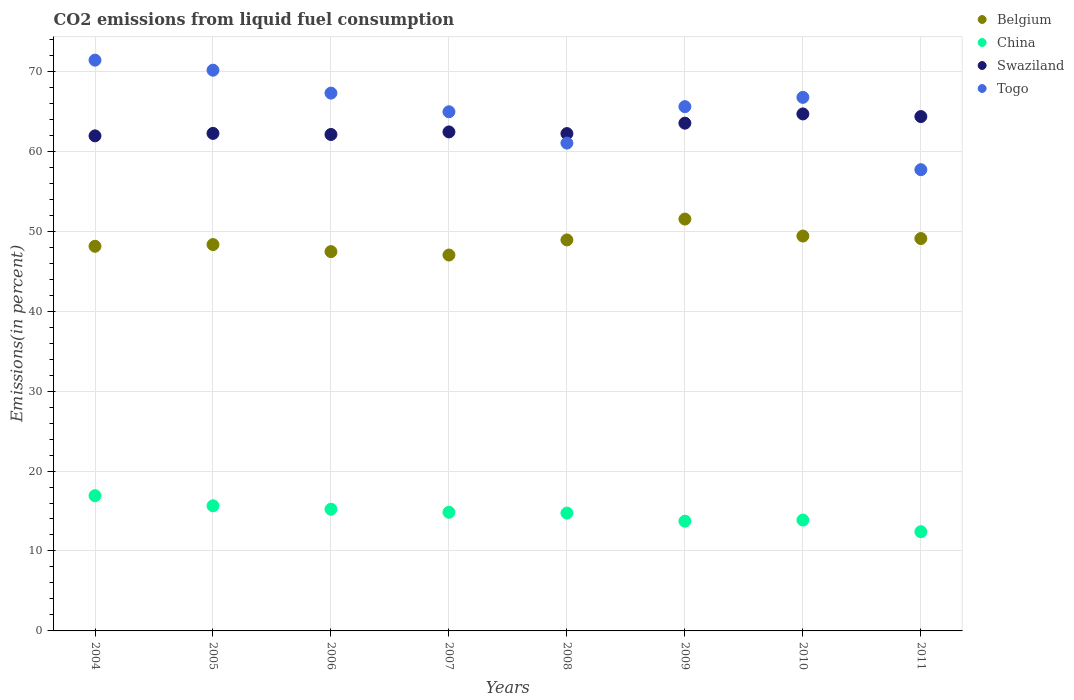What is the total CO2 emitted in China in 2010?
Provide a succinct answer. 13.87. Across all years, what is the maximum total CO2 emitted in China?
Ensure brevity in your answer.  16.91. Across all years, what is the minimum total CO2 emitted in China?
Make the answer very short. 12.41. In which year was the total CO2 emitted in Belgium maximum?
Ensure brevity in your answer.  2009. In which year was the total CO2 emitted in China minimum?
Keep it short and to the point. 2011. What is the total total CO2 emitted in Belgium in the graph?
Make the answer very short. 389.78. What is the difference between the total CO2 emitted in China in 2006 and that in 2008?
Provide a succinct answer. 0.48. What is the difference between the total CO2 emitted in Belgium in 2005 and the total CO2 emitted in Togo in 2008?
Ensure brevity in your answer.  -12.69. What is the average total CO2 emitted in Belgium per year?
Your answer should be very brief. 48.72. In the year 2009, what is the difference between the total CO2 emitted in China and total CO2 emitted in Belgium?
Provide a short and direct response. -37.79. What is the ratio of the total CO2 emitted in Belgium in 2009 to that in 2010?
Offer a terse response. 1.04. Is the total CO2 emitted in Belgium in 2004 less than that in 2010?
Make the answer very short. Yes. Is the difference between the total CO2 emitted in China in 2007 and 2009 greater than the difference between the total CO2 emitted in Belgium in 2007 and 2009?
Your answer should be very brief. Yes. What is the difference between the highest and the second highest total CO2 emitted in Belgium?
Offer a very short reply. 2.12. What is the difference between the highest and the lowest total CO2 emitted in China?
Offer a terse response. 4.5. Is the sum of the total CO2 emitted in China in 2004 and 2010 greater than the maximum total CO2 emitted in Belgium across all years?
Offer a very short reply. No. Is the total CO2 emitted in Togo strictly greater than the total CO2 emitted in China over the years?
Ensure brevity in your answer.  Yes. Is the total CO2 emitted in Swaziland strictly less than the total CO2 emitted in Belgium over the years?
Offer a terse response. No. How many dotlines are there?
Your response must be concise. 4. How many years are there in the graph?
Make the answer very short. 8. What is the difference between two consecutive major ticks on the Y-axis?
Provide a succinct answer. 10. How are the legend labels stacked?
Keep it short and to the point. Vertical. What is the title of the graph?
Give a very brief answer. CO2 emissions from liquid fuel consumption. What is the label or title of the X-axis?
Offer a very short reply. Years. What is the label or title of the Y-axis?
Your answer should be compact. Emissions(in percent). What is the Emissions(in percent) of Belgium in 2004?
Give a very brief answer. 48.11. What is the Emissions(in percent) in China in 2004?
Your answer should be very brief. 16.91. What is the Emissions(in percent) in Swaziland in 2004?
Provide a succinct answer. 61.92. What is the Emissions(in percent) of Togo in 2004?
Your answer should be very brief. 71.39. What is the Emissions(in percent) of Belgium in 2005?
Ensure brevity in your answer.  48.33. What is the Emissions(in percent) of China in 2005?
Your response must be concise. 15.65. What is the Emissions(in percent) in Swaziland in 2005?
Your answer should be compact. 62.23. What is the Emissions(in percent) in Togo in 2005?
Offer a very short reply. 70.14. What is the Emissions(in percent) of Belgium in 2006?
Your answer should be very brief. 47.44. What is the Emissions(in percent) of China in 2006?
Give a very brief answer. 15.22. What is the Emissions(in percent) of Swaziland in 2006?
Keep it short and to the point. 62.09. What is the Emissions(in percent) in Togo in 2006?
Your answer should be very brief. 67.27. What is the Emissions(in percent) in Belgium in 2007?
Offer a very short reply. 47.02. What is the Emissions(in percent) in China in 2007?
Make the answer very short. 14.84. What is the Emissions(in percent) in Swaziland in 2007?
Offer a very short reply. 62.41. What is the Emissions(in percent) in Togo in 2007?
Keep it short and to the point. 64.94. What is the Emissions(in percent) of Belgium in 2008?
Give a very brief answer. 48.9. What is the Emissions(in percent) in China in 2008?
Your answer should be compact. 14.74. What is the Emissions(in percent) in Swaziland in 2008?
Provide a short and direct response. 62.21. What is the Emissions(in percent) in Togo in 2008?
Make the answer very short. 61.02. What is the Emissions(in percent) in Belgium in 2009?
Provide a short and direct response. 51.51. What is the Emissions(in percent) of China in 2009?
Offer a terse response. 13.73. What is the Emissions(in percent) in Swaziland in 2009?
Keep it short and to the point. 63.51. What is the Emissions(in percent) of Togo in 2009?
Make the answer very short. 65.58. What is the Emissions(in percent) in Belgium in 2010?
Offer a very short reply. 49.39. What is the Emissions(in percent) of China in 2010?
Provide a succinct answer. 13.87. What is the Emissions(in percent) of Swaziland in 2010?
Offer a very short reply. 64.66. What is the Emissions(in percent) in Togo in 2010?
Ensure brevity in your answer.  66.74. What is the Emissions(in percent) of Belgium in 2011?
Your response must be concise. 49.08. What is the Emissions(in percent) of China in 2011?
Provide a succinct answer. 12.41. What is the Emissions(in percent) of Swaziland in 2011?
Give a very brief answer. 64.34. What is the Emissions(in percent) in Togo in 2011?
Your response must be concise. 57.69. Across all years, what is the maximum Emissions(in percent) of Belgium?
Offer a very short reply. 51.51. Across all years, what is the maximum Emissions(in percent) of China?
Provide a short and direct response. 16.91. Across all years, what is the maximum Emissions(in percent) in Swaziland?
Your answer should be compact. 64.66. Across all years, what is the maximum Emissions(in percent) of Togo?
Offer a terse response. 71.39. Across all years, what is the minimum Emissions(in percent) in Belgium?
Your answer should be compact. 47.02. Across all years, what is the minimum Emissions(in percent) in China?
Offer a terse response. 12.41. Across all years, what is the minimum Emissions(in percent) of Swaziland?
Give a very brief answer. 61.92. Across all years, what is the minimum Emissions(in percent) in Togo?
Provide a succinct answer. 57.69. What is the total Emissions(in percent) of Belgium in the graph?
Your answer should be very brief. 389.78. What is the total Emissions(in percent) of China in the graph?
Offer a very short reply. 117.37. What is the total Emissions(in percent) of Swaziland in the graph?
Provide a succinct answer. 503.38. What is the total Emissions(in percent) in Togo in the graph?
Your response must be concise. 524.75. What is the difference between the Emissions(in percent) of Belgium in 2004 and that in 2005?
Provide a succinct answer. -0.22. What is the difference between the Emissions(in percent) of China in 2004 and that in 2005?
Your answer should be compact. 1.26. What is the difference between the Emissions(in percent) of Swaziland in 2004 and that in 2005?
Make the answer very short. -0.31. What is the difference between the Emissions(in percent) in Togo in 2004 and that in 2005?
Ensure brevity in your answer.  1.25. What is the difference between the Emissions(in percent) of Belgium in 2004 and that in 2006?
Your answer should be very brief. 0.67. What is the difference between the Emissions(in percent) in China in 2004 and that in 2006?
Your answer should be compact. 1.69. What is the difference between the Emissions(in percent) of Swaziland in 2004 and that in 2006?
Your response must be concise. -0.17. What is the difference between the Emissions(in percent) in Togo in 2004 and that in 2006?
Your answer should be compact. 4.12. What is the difference between the Emissions(in percent) of Belgium in 2004 and that in 2007?
Provide a short and direct response. 1.09. What is the difference between the Emissions(in percent) in China in 2004 and that in 2007?
Ensure brevity in your answer.  2.07. What is the difference between the Emissions(in percent) of Swaziland in 2004 and that in 2007?
Offer a very short reply. -0.49. What is the difference between the Emissions(in percent) in Togo in 2004 and that in 2007?
Your response must be concise. 6.46. What is the difference between the Emissions(in percent) of Belgium in 2004 and that in 2008?
Your answer should be very brief. -0.79. What is the difference between the Emissions(in percent) in China in 2004 and that in 2008?
Keep it short and to the point. 2.17. What is the difference between the Emissions(in percent) in Swaziland in 2004 and that in 2008?
Your response must be concise. -0.29. What is the difference between the Emissions(in percent) in Togo in 2004 and that in 2008?
Offer a terse response. 10.37. What is the difference between the Emissions(in percent) of Belgium in 2004 and that in 2009?
Keep it short and to the point. -3.4. What is the difference between the Emissions(in percent) in China in 2004 and that in 2009?
Provide a succinct answer. 3.19. What is the difference between the Emissions(in percent) of Swaziland in 2004 and that in 2009?
Provide a short and direct response. -1.59. What is the difference between the Emissions(in percent) in Togo in 2004 and that in 2009?
Provide a succinct answer. 5.81. What is the difference between the Emissions(in percent) in Belgium in 2004 and that in 2010?
Provide a short and direct response. -1.28. What is the difference between the Emissions(in percent) of China in 2004 and that in 2010?
Your response must be concise. 3.04. What is the difference between the Emissions(in percent) of Swaziland in 2004 and that in 2010?
Your response must be concise. -2.74. What is the difference between the Emissions(in percent) of Togo in 2004 and that in 2010?
Provide a succinct answer. 4.65. What is the difference between the Emissions(in percent) of Belgium in 2004 and that in 2011?
Provide a succinct answer. -0.97. What is the difference between the Emissions(in percent) of China in 2004 and that in 2011?
Your answer should be compact. 4.5. What is the difference between the Emissions(in percent) in Swaziland in 2004 and that in 2011?
Make the answer very short. -2.41. What is the difference between the Emissions(in percent) of Togo in 2004 and that in 2011?
Your response must be concise. 13.7. What is the difference between the Emissions(in percent) of Belgium in 2005 and that in 2006?
Make the answer very short. 0.88. What is the difference between the Emissions(in percent) of China in 2005 and that in 2006?
Provide a succinct answer. 0.43. What is the difference between the Emissions(in percent) of Swaziland in 2005 and that in 2006?
Keep it short and to the point. 0.14. What is the difference between the Emissions(in percent) in Togo in 2005 and that in 2006?
Keep it short and to the point. 2.87. What is the difference between the Emissions(in percent) of Belgium in 2005 and that in 2007?
Keep it short and to the point. 1.31. What is the difference between the Emissions(in percent) of China in 2005 and that in 2007?
Ensure brevity in your answer.  0.81. What is the difference between the Emissions(in percent) of Swaziland in 2005 and that in 2007?
Provide a short and direct response. -0.18. What is the difference between the Emissions(in percent) in Togo in 2005 and that in 2007?
Ensure brevity in your answer.  5.2. What is the difference between the Emissions(in percent) of Belgium in 2005 and that in 2008?
Keep it short and to the point. -0.58. What is the difference between the Emissions(in percent) of China in 2005 and that in 2008?
Make the answer very short. 0.91. What is the difference between the Emissions(in percent) of Swaziland in 2005 and that in 2008?
Provide a succinct answer. 0.02. What is the difference between the Emissions(in percent) in Togo in 2005 and that in 2008?
Ensure brevity in your answer.  9.12. What is the difference between the Emissions(in percent) of Belgium in 2005 and that in 2009?
Offer a terse response. -3.19. What is the difference between the Emissions(in percent) of China in 2005 and that in 2009?
Your answer should be compact. 1.93. What is the difference between the Emissions(in percent) of Swaziland in 2005 and that in 2009?
Give a very brief answer. -1.28. What is the difference between the Emissions(in percent) in Togo in 2005 and that in 2009?
Offer a very short reply. 4.56. What is the difference between the Emissions(in percent) of Belgium in 2005 and that in 2010?
Offer a very short reply. -1.07. What is the difference between the Emissions(in percent) of China in 2005 and that in 2010?
Offer a very short reply. 1.78. What is the difference between the Emissions(in percent) in Swaziland in 2005 and that in 2010?
Keep it short and to the point. -2.43. What is the difference between the Emissions(in percent) in Togo in 2005 and that in 2010?
Offer a terse response. 3.4. What is the difference between the Emissions(in percent) of Belgium in 2005 and that in 2011?
Ensure brevity in your answer.  -0.75. What is the difference between the Emissions(in percent) in China in 2005 and that in 2011?
Make the answer very short. 3.24. What is the difference between the Emissions(in percent) of Swaziland in 2005 and that in 2011?
Your answer should be very brief. -2.11. What is the difference between the Emissions(in percent) in Togo in 2005 and that in 2011?
Provide a succinct answer. 12.44. What is the difference between the Emissions(in percent) in Belgium in 2006 and that in 2007?
Ensure brevity in your answer.  0.42. What is the difference between the Emissions(in percent) of China in 2006 and that in 2007?
Provide a succinct answer. 0.38. What is the difference between the Emissions(in percent) of Swaziland in 2006 and that in 2007?
Provide a succinct answer. -0.32. What is the difference between the Emissions(in percent) in Togo in 2006 and that in 2007?
Provide a short and direct response. 2.33. What is the difference between the Emissions(in percent) in Belgium in 2006 and that in 2008?
Keep it short and to the point. -1.46. What is the difference between the Emissions(in percent) of China in 2006 and that in 2008?
Provide a succinct answer. 0.48. What is the difference between the Emissions(in percent) in Swaziland in 2006 and that in 2008?
Ensure brevity in your answer.  -0.11. What is the difference between the Emissions(in percent) in Togo in 2006 and that in 2008?
Ensure brevity in your answer.  6.25. What is the difference between the Emissions(in percent) in Belgium in 2006 and that in 2009?
Give a very brief answer. -4.07. What is the difference between the Emissions(in percent) of China in 2006 and that in 2009?
Your answer should be compact. 1.49. What is the difference between the Emissions(in percent) in Swaziland in 2006 and that in 2009?
Your answer should be compact. -1.41. What is the difference between the Emissions(in percent) of Togo in 2006 and that in 2009?
Offer a terse response. 1.69. What is the difference between the Emissions(in percent) in Belgium in 2006 and that in 2010?
Give a very brief answer. -1.95. What is the difference between the Emissions(in percent) of China in 2006 and that in 2010?
Your response must be concise. 1.35. What is the difference between the Emissions(in percent) in Swaziland in 2006 and that in 2010?
Your answer should be very brief. -2.57. What is the difference between the Emissions(in percent) in Togo in 2006 and that in 2010?
Your answer should be very brief. 0.53. What is the difference between the Emissions(in percent) in Belgium in 2006 and that in 2011?
Provide a succinct answer. -1.64. What is the difference between the Emissions(in percent) in China in 2006 and that in 2011?
Your answer should be very brief. 2.81. What is the difference between the Emissions(in percent) of Swaziland in 2006 and that in 2011?
Offer a very short reply. -2.24. What is the difference between the Emissions(in percent) of Togo in 2006 and that in 2011?
Give a very brief answer. 9.57. What is the difference between the Emissions(in percent) of Belgium in 2007 and that in 2008?
Give a very brief answer. -1.89. What is the difference between the Emissions(in percent) of China in 2007 and that in 2008?
Give a very brief answer. 0.1. What is the difference between the Emissions(in percent) of Swaziland in 2007 and that in 2008?
Keep it short and to the point. 0.21. What is the difference between the Emissions(in percent) of Togo in 2007 and that in 2008?
Your answer should be very brief. 3.92. What is the difference between the Emissions(in percent) of Belgium in 2007 and that in 2009?
Provide a succinct answer. -4.5. What is the difference between the Emissions(in percent) of China in 2007 and that in 2009?
Give a very brief answer. 1.11. What is the difference between the Emissions(in percent) in Swaziland in 2007 and that in 2009?
Provide a short and direct response. -1.09. What is the difference between the Emissions(in percent) in Togo in 2007 and that in 2009?
Provide a short and direct response. -0.64. What is the difference between the Emissions(in percent) in Belgium in 2007 and that in 2010?
Your response must be concise. -2.37. What is the difference between the Emissions(in percent) of China in 2007 and that in 2010?
Your response must be concise. 0.97. What is the difference between the Emissions(in percent) of Swaziland in 2007 and that in 2010?
Provide a short and direct response. -2.25. What is the difference between the Emissions(in percent) in Togo in 2007 and that in 2010?
Give a very brief answer. -1.8. What is the difference between the Emissions(in percent) of Belgium in 2007 and that in 2011?
Keep it short and to the point. -2.06. What is the difference between the Emissions(in percent) of China in 2007 and that in 2011?
Ensure brevity in your answer.  2.43. What is the difference between the Emissions(in percent) of Swaziland in 2007 and that in 2011?
Offer a very short reply. -1.92. What is the difference between the Emissions(in percent) in Togo in 2007 and that in 2011?
Your answer should be very brief. 7.24. What is the difference between the Emissions(in percent) in Belgium in 2008 and that in 2009?
Your answer should be compact. -2.61. What is the difference between the Emissions(in percent) in China in 2008 and that in 2009?
Your answer should be very brief. 1.01. What is the difference between the Emissions(in percent) of Swaziland in 2008 and that in 2009?
Your answer should be compact. -1.3. What is the difference between the Emissions(in percent) in Togo in 2008 and that in 2009?
Give a very brief answer. -4.56. What is the difference between the Emissions(in percent) of Belgium in 2008 and that in 2010?
Provide a succinct answer. -0.49. What is the difference between the Emissions(in percent) of China in 2008 and that in 2010?
Make the answer very short. 0.87. What is the difference between the Emissions(in percent) of Swaziland in 2008 and that in 2010?
Your answer should be compact. -2.46. What is the difference between the Emissions(in percent) of Togo in 2008 and that in 2010?
Keep it short and to the point. -5.72. What is the difference between the Emissions(in percent) in Belgium in 2008 and that in 2011?
Your answer should be compact. -0.18. What is the difference between the Emissions(in percent) in China in 2008 and that in 2011?
Ensure brevity in your answer.  2.33. What is the difference between the Emissions(in percent) in Swaziland in 2008 and that in 2011?
Your answer should be very brief. -2.13. What is the difference between the Emissions(in percent) in Togo in 2008 and that in 2011?
Your answer should be compact. 3.32. What is the difference between the Emissions(in percent) of Belgium in 2009 and that in 2010?
Keep it short and to the point. 2.12. What is the difference between the Emissions(in percent) of China in 2009 and that in 2010?
Your answer should be compact. -0.14. What is the difference between the Emissions(in percent) in Swaziland in 2009 and that in 2010?
Ensure brevity in your answer.  -1.16. What is the difference between the Emissions(in percent) in Togo in 2009 and that in 2010?
Provide a short and direct response. -1.16. What is the difference between the Emissions(in percent) of Belgium in 2009 and that in 2011?
Keep it short and to the point. 2.43. What is the difference between the Emissions(in percent) of China in 2009 and that in 2011?
Your answer should be compact. 1.32. What is the difference between the Emissions(in percent) in Swaziland in 2009 and that in 2011?
Provide a short and direct response. -0.83. What is the difference between the Emissions(in percent) of Togo in 2009 and that in 2011?
Your answer should be very brief. 7.88. What is the difference between the Emissions(in percent) in Belgium in 2010 and that in 2011?
Your answer should be very brief. 0.31. What is the difference between the Emissions(in percent) in China in 2010 and that in 2011?
Ensure brevity in your answer.  1.46. What is the difference between the Emissions(in percent) of Swaziland in 2010 and that in 2011?
Offer a terse response. 0.33. What is the difference between the Emissions(in percent) in Togo in 2010 and that in 2011?
Provide a succinct answer. 9.05. What is the difference between the Emissions(in percent) of Belgium in 2004 and the Emissions(in percent) of China in 2005?
Keep it short and to the point. 32.46. What is the difference between the Emissions(in percent) of Belgium in 2004 and the Emissions(in percent) of Swaziland in 2005?
Offer a terse response. -14.12. What is the difference between the Emissions(in percent) of Belgium in 2004 and the Emissions(in percent) of Togo in 2005?
Make the answer very short. -22.03. What is the difference between the Emissions(in percent) of China in 2004 and the Emissions(in percent) of Swaziland in 2005?
Keep it short and to the point. -45.32. What is the difference between the Emissions(in percent) of China in 2004 and the Emissions(in percent) of Togo in 2005?
Offer a terse response. -53.22. What is the difference between the Emissions(in percent) of Swaziland in 2004 and the Emissions(in percent) of Togo in 2005?
Your answer should be very brief. -8.22. What is the difference between the Emissions(in percent) of Belgium in 2004 and the Emissions(in percent) of China in 2006?
Offer a very short reply. 32.89. What is the difference between the Emissions(in percent) in Belgium in 2004 and the Emissions(in percent) in Swaziland in 2006?
Provide a short and direct response. -13.98. What is the difference between the Emissions(in percent) of Belgium in 2004 and the Emissions(in percent) of Togo in 2006?
Ensure brevity in your answer.  -19.16. What is the difference between the Emissions(in percent) in China in 2004 and the Emissions(in percent) in Swaziland in 2006?
Provide a succinct answer. -45.18. What is the difference between the Emissions(in percent) in China in 2004 and the Emissions(in percent) in Togo in 2006?
Make the answer very short. -50.35. What is the difference between the Emissions(in percent) in Swaziland in 2004 and the Emissions(in percent) in Togo in 2006?
Your answer should be compact. -5.35. What is the difference between the Emissions(in percent) in Belgium in 2004 and the Emissions(in percent) in China in 2007?
Give a very brief answer. 33.27. What is the difference between the Emissions(in percent) of Belgium in 2004 and the Emissions(in percent) of Swaziland in 2007?
Your answer should be compact. -14.3. What is the difference between the Emissions(in percent) in Belgium in 2004 and the Emissions(in percent) in Togo in 2007?
Keep it short and to the point. -16.82. What is the difference between the Emissions(in percent) of China in 2004 and the Emissions(in percent) of Swaziland in 2007?
Your answer should be compact. -45.5. What is the difference between the Emissions(in percent) of China in 2004 and the Emissions(in percent) of Togo in 2007?
Your answer should be very brief. -48.02. What is the difference between the Emissions(in percent) in Swaziland in 2004 and the Emissions(in percent) in Togo in 2007?
Make the answer very short. -3.01. What is the difference between the Emissions(in percent) in Belgium in 2004 and the Emissions(in percent) in China in 2008?
Provide a succinct answer. 33.37. What is the difference between the Emissions(in percent) in Belgium in 2004 and the Emissions(in percent) in Swaziland in 2008?
Give a very brief answer. -14.1. What is the difference between the Emissions(in percent) in Belgium in 2004 and the Emissions(in percent) in Togo in 2008?
Keep it short and to the point. -12.91. What is the difference between the Emissions(in percent) in China in 2004 and the Emissions(in percent) in Swaziland in 2008?
Ensure brevity in your answer.  -45.29. What is the difference between the Emissions(in percent) in China in 2004 and the Emissions(in percent) in Togo in 2008?
Make the answer very short. -44.1. What is the difference between the Emissions(in percent) in Swaziland in 2004 and the Emissions(in percent) in Togo in 2008?
Keep it short and to the point. 0.9. What is the difference between the Emissions(in percent) of Belgium in 2004 and the Emissions(in percent) of China in 2009?
Ensure brevity in your answer.  34.38. What is the difference between the Emissions(in percent) of Belgium in 2004 and the Emissions(in percent) of Swaziland in 2009?
Your answer should be very brief. -15.4. What is the difference between the Emissions(in percent) of Belgium in 2004 and the Emissions(in percent) of Togo in 2009?
Provide a succinct answer. -17.47. What is the difference between the Emissions(in percent) in China in 2004 and the Emissions(in percent) in Swaziland in 2009?
Make the answer very short. -46.6. What is the difference between the Emissions(in percent) in China in 2004 and the Emissions(in percent) in Togo in 2009?
Offer a very short reply. -48.66. What is the difference between the Emissions(in percent) in Swaziland in 2004 and the Emissions(in percent) in Togo in 2009?
Provide a short and direct response. -3.66. What is the difference between the Emissions(in percent) in Belgium in 2004 and the Emissions(in percent) in China in 2010?
Ensure brevity in your answer.  34.24. What is the difference between the Emissions(in percent) in Belgium in 2004 and the Emissions(in percent) in Swaziland in 2010?
Give a very brief answer. -16.55. What is the difference between the Emissions(in percent) of Belgium in 2004 and the Emissions(in percent) of Togo in 2010?
Provide a succinct answer. -18.63. What is the difference between the Emissions(in percent) of China in 2004 and the Emissions(in percent) of Swaziland in 2010?
Your answer should be very brief. -47.75. What is the difference between the Emissions(in percent) of China in 2004 and the Emissions(in percent) of Togo in 2010?
Your response must be concise. -49.82. What is the difference between the Emissions(in percent) in Swaziland in 2004 and the Emissions(in percent) in Togo in 2010?
Give a very brief answer. -4.82. What is the difference between the Emissions(in percent) in Belgium in 2004 and the Emissions(in percent) in China in 2011?
Give a very brief answer. 35.7. What is the difference between the Emissions(in percent) in Belgium in 2004 and the Emissions(in percent) in Swaziland in 2011?
Your answer should be very brief. -16.23. What is the difference between the Emissions(in percent) of Belgium in 2004 and the Emissions(in percent) of Togo in 2011?
Keep it short and to the point. -9.58. What is the difference between the Emissions(in percent) in China in 2004 and the Emissions(in percent) in Swaziland in 2011?
Make the answer very short. -47.42. What is the difference between the Emissions(in percent) of China in 2004 and the Emissions(in percent) of Togo in 2011?
Make the answer very short. -40.78. What is the difference between the Emissions(in percent) in Swaziland in 2004 and the Emissions(in percent) in Togo in 2011?
Keep it short and to the point. 4.23. What is the difference between the Emissions(in percent) in Belgium in 2005 and the Emissions(in percent) in China in 2006?
Ensure brevity in your answer.  33.1. What is the difference between the Emissions(in percent) of Belgium in 2005 and the Emissions(in percent) of Swaziland in 2006?
Keep it short and to the point. -13.77. What is the difference between the Emissions(in percent) in Belgium in 2005 and the Emissions(in percent) in Togo in 2006?
Keep it short and to the point. -18.94. What is the difference between the Emissions(in percent) in China in 2005 and the Emissions(in percent) in Swaziland in 2006?
Offer a terse response. -46.44. What is the difference between the Emissions(in percent) of China in 2005 and the Emissions(in percent) of Togo in 2006?
Provide a short and direct response. -51.62. What is the difference between the Emissions(in percent) of Swaziland in 2005 and the Emissions(in percent) of Togo in 2006?
Provide a short and direct response. -5.04. What is the difference between the Emissions(in percent) of Belgium in 2005 and the Emissions(in percent) of China in 2007?
Keep it short and to the point. 33.49. What is the difference between the Emissions(in percent) of Belgium in 2005 and the Emissions(in percent) of Swaziland in 2007?
Offer a terse response. -14.09. What is the difference between the Emissions(in percent) in Belgium in 2005 and the Emissions(in percent) in Togo in 2007?
Keep it short and to the point. -16.61. What is the difference between the Emissions(in percent) in China in 2005 and the Emissions(in percent) in Swaziland in 2007?
Offer a terse response. -46.76. What is the difference between the Emissions(in percent) in China in 2005 and the Emissions(in percent) in Togo in 2007?
Offer a very short reply. -49.28. What is the difference between the Emissions(in percent) in Swaziland in 2005 and the Emissions(in percent) in Togo in 2007?
Make the answer very short. -2.7. What is the difference between the Emissions(in percent) of Belgium in 2005 and the Emissions(in percent) of China in 2008?
Provide a short and direct response. 33.59. What is the difference between the Emissions(in percent) in Belgium in 2005 and the Emissions(in percent) in Swaziland in 2008?
Provide a short and direct response. -13.88. What is the difference between the Emissions(in percent) of Belgium in 2005 and the Emissions(in percent) of Togo in 2008?
Give a very brief answer. -12.69. What is the difference between the Emissions(in percent) in China in 2005 and the Emissions(in percent) in Swaziland in 2008?
Your response must be concise. -46.56. What is the difference between the Emissions(in percent) of China in 2005 and the Emissions(in percent) of Togo in 2008?
Give a very brief answer. -45.37. What is the difference between the Emissions(in percent) in Swaziland in 2005 and the Emissions(in percent) in Togo in 2008?
Provide a succinct answer. 1.21. What is the difference between the Emissions(in percent) in Belgium in 2005 and the Emissions(in percent) in China in 2009?
Provide a succinct answer. 34.6. What is the difference between the Emissions(in percent) of Belgium in 2005 and the Emissions(in percent) of Swaziland in 2009?
Your answer should be compact. -15.18. What is the difference between the Emissions(in percent) in Belgium in 2005 and the Emissions(in percent) in Togo in 2009?
Ensure brevity in your answer.  -17.25. What is the difference between the Emissions(in percent) in China in 2005 and the Emissions(in percent) in Swaziland in 2009?
Give a very brief answer. -47.86. What is the difference between the Emissions(in percent) of China in 2005 and the Emissions(in percent) of Togo in 2009?
Your answer should be very brief. -49.93. What is the difference between the Emissions(in percent) of Swaziland in 2005 and the Emissions(in percent) of Togo in 2009?
Your answer should be compact. -3.35. What is the difference between the Emissions(in percent) in Belgium in 2005 and the Emissions(in percent) in China in 2010?
Offer a very short reply. 34.46. What is the difference between the Emissions(in percent) in Belgium in 2005 and the Emissions(in percent) in Swaziland in 2010?
Your answer should be compact. -16.34. What is the difference between the Emissions(in percent) of Belgium in 2005 and the Emissions(in percent) of Togo in 2010?
Your answer should be compact. -18.41. What is the difference between the Emissions(in percent) of China in 2005 and the Emissions(in percent) of Swaziland in 2010?
Provide a short and direct response. -49.01. What is the difference between the Emissions(in percent) in China in 2005 and the Emissions(in percent) in Togo in 2010?
Give a very brief answer. -51.09. What is the difference between the Emissions(in percent) of Swaziland in 2005 and the Emissions(in percent) of Togo in 2010?
Make the answer very short. -4.51. What is the difference between the Emissions(in percent) of Belgium in 2005 and the Emissions(in percent) of China in 2011?
Provide a short and direct response. 35.92. What is the difference between the Emissions(in percent) of Belgium in 2005 and the Emissions(in percent) of Swaziland in 2011?
Keep it short and to the point. -16.01. What is the difference between the Emissions(in percent) in Belgium in 2005 and the Emissions(in percent) in Togo in 2011?
Keep it short and to the point. -9.37. What is the difference between the Emissions(in percent) of China in 2005 and the Emissions(in percent) of Swaziland in 2011?
Offer a very short reply. -48.68. What is the difference between the Emissions(in percent) of China in 2005 and the Emissions(in percent) of Togo in 2011?
Keep it short and to the point. -42.04. What is the difference between the Emissions(in percent) of Swaziland in 2005 and the Emissions(in percent) of Togo in 2011?
Your answer should be compact. 4.54. What is the difference between the Emissions(in percent) of Belgium in 2006 and the Emissions(in percent) of China in 2007?
Your answer should be compact. 32.6. What is the difference between the Emissions(in percent) of Belgium in 2006 and the Emissions(in percent) of Swaziland in 2007?
Provide a succinct answer. -14.97. What is the difference between the Emissions(in percent) of Belgium in 2006 and the Emissions(in percent) of Togo in 2007?
Provide a succinct answer. -17.49. What is the difference between the Emissions(in percent) in China in 2006 and the Emissions(in percent) in Swaziland in 2007?
Keep it short and to the point. -47.19. What is the difference between the Emissions(in percent) in China in 2006 and the Emissions(in percent) in Togo in 2007?
Your answer should be very brief. -49.71. What is the difference between the Emissions(in percent) in Swaziland in 2006 and the Emissions(in percent) in Togo in 2007?
Provide a succinct answer. -2.84. What is the difference between the Emissions(in percent) in Belgium in 2006 and the Emissions(in percent) in China in 2008?
Your response must be concise. 32.7. What is the difference between the Emissions(in percent) in Belgium in 2006 and the Emissions(in percent) in Swaziland in 2008?
Your response must be concise. -14.77. What is the difference between the Emissions(in percent) of Belgium in 2006 and the Emissions(in percent) of Togo in 2008?
Provide a succinct answer. -13.58. What is the difference between the Emissions(in percent) of China in 2006 and the Emissions(in percent) of Swaziland in 2008?
Your answer should be very brief. -46.99. What is the difference between the Emissions(in percent) of China in 2006 and the Emissions(in percent) of Togo in 2008?
Provide a short and direct response. -45.8. What is the difference between the Emissions(in percent) of Swaziland in 2006 and the Emissions(in percent) of Togo in 2008?
Ensure brevity in your answer.  1.08. What is the difference between the Emissions(in percent) in Belgium in 2006 and the Emissions(in percent) in China in 2009?
Your answer should be very brief. 33.72. What is the difference between the Emissions(in percent) in Belgium in 2006 and the Emissions(in percent) in Swaziland in 2009?
Give a very brief answer. -16.07. What is the difference between the Emissions(in percent) of Belgium in 2006 and the Emissions(in percent) of Togo in 2009?
Your answer should be compact. -18.14. What is the difference between the Emissions(in percent) of China in 2006 and the Emissions(in percent) of Swaziland in 2009?
Your response must be concise. -48.29. What is the difference between the Emissions(in percent) of China in 2006 and the Emissions(in percent) of Togo in 2009?
Keep it short and to the point. -50.36. What is the difference between the Emissions(in percent) of Swaziland in 2006 and the Emissions(in percent) of Togo in 2009?
Your response must be concise. -3.48. What is the difference between the Emissions(in percent) of Belgium in 2006 and the Emissions(in percent) of China in 2010?
Ensure brevity in your answer.  33.57. What is the difference between the Emissions(in percent) of Belgium in 2006 and the Emissions(in percent) of Swaziland in 2010?
Provide a short and direct response. -17.22. What is the difference between the Emissions(in percent) of Belgium in 2006 and the Emissions(in percent) of Togo in 2010?
Provide a short and direct response. -19.3. What is the difference between the Emissions(in percent) in China in 2006 and the Emissions(in percent) in Swaziland in 2010?
Provide a succinct answer. -49.44. What is the difference between the Emissions(in percent) in China in 2006 and the Emissions(in percent) in Togo in 2010?
Keep it short and to the point. -51.52. What is the difference between the Emissions(in percent) in Swaziland in 2006 and the Emissions(in percent) in Togo in 2010?
Give a very brief answer. -4.64. What is the difference between the Emissions(in percent) in Belgium in 2006 and the Emissions(in percent) in China in 2011?
Offer a very short reply. 35.03. What is the difference between the Emissions(in percent) in Belgium in 2006 and the Emissions(in percent) in Swaziland in 2011?
Ensure brevity in your answer.  -16.89. What is the difference between the Emissions(in percent) of Belgium in 2006 and the Emissions(in percent) of Togo in 2011?
Offer a very short reply. -10.25. What is the difference between the Emissions(in percent) of China in 2006 and the Emissions(in percent) of Swaziland in 2011?
Your answer should be very brief. -49.11. What is the difference between the Emissions(in percent) of China in 2006 and the Emissions(in percent) of Togo in 2011?
Offer a very short reply. -42.47. What is the difference between the Emissions(in percent) in Swaziland in 2006 and the Emissions(in percent) in Togo in 2011?
Provide a succinct answer. 4.4. What is the difference between the Emissions(in percent) of Belgium in 2007 and the Emissions(in percent) of China in 2008?
Ensure brevity in your answer.  32.28. What is the difference between the Emissions(in percent) in Belgium in 2007 and the Emissions(in percent) in Swaziland in 2008?
Keep it short and to the point. -15.19. What is the difference between the Emissions(in percent) of Belgium in 2007 and the Emissions(in percent) of Togo in 2008?
Make the answer very short. -14. What is the difference between the Emissions(in percent) of China in 2007 and the Emissions(in percent) of Swaziland in 2008?
Keep it short and to the point. -47.37. What is the difference between the Emissions(in percent) in China in 2007 and the Emissions(in percent) in Togo in 2008?
Keep it short and to the point. -46.18. What is the difference between the Emissions(in percent) of Swaziland in 2007 and the Emissions(in percent) of Togo in 2008?
Make the answer very short. 1.4. What is the difference between the Emissions(in percent) in Belgium in 2007 and the Emissions(in percent) in China in 2009?
Ensure brevity in your answer.  33.29. What is the difference between the Emissions(in percent) in Belgium in 2007 and the Emissions(in percent) in Swaziland in 2009?
Offer a very short reply. -16.49. What is the difference between the Emissions(in percent) of Belgium in 2007 and the Emissions(in percent) of Togo in 2009?
Offer a terse response. -18.56. What is the difference between the Emissions(in percent) of China in 2007 and the Emissions(in percent) of Swaziland in 2009?
Offer a very short reply. -48.67. What is the difference between the Emissions(in percent) of China in 2007 and the Emissions(in percent) of Togo in 2009?
Offer a very short reply. -50.74. What is the difference between the Emissions(in percent) in Swaziland in 2007 and the Emissions(in percent) in Togo in 2009?
Provide a succinct answer. -3.16. What is the difference between the Emissions(in percent) in Belgium in 2007 and the Emissions(in percent) in China in 2010?
Make the answer very short. 33.15. What is the difference between the Emissions(in percent) of Belgium in 2007 and the Emissions(in percent) of Swaziland in 2010?
Ensure brevity in your answer.  -17.65. What is the difference between the Emissions(in percent) of Belgium in 2007 and the Emissions(in percent) of Togo in 2010?
Your answer should be very brief. -19.72. What is the difference between the Emissions(in percent) in China in 2007 and the Emissions(in percent) in Swaziland in 2010?
Offer a terse response. -49.83. What is the difference between the Emissions(in percent) of China in 2007 and the Emissions(in percent) of Togo in 2010?
Offer a very short reply. -51.9. What is the difference between the Emissions(in percent) of Swaziland in 2007 and the Emissions(in percent) of Togo in 2010?
Keep it short and to the point. -4.32. What is the difference between the Emissions(in percent) of Belgium in 2007 and the Emissions(in percent) of China in 2011?
Offer a very short reply. 34.61. What is the difference between the Emissions(in percent) in Belgium in 2007 and the Emissions(in percent) in Swaziland in 2011?
Keep it short and to the point. -17.32. What is the difference between the Emissions(in percent) in Belgium in 2007 and the Emissions(in percent) in Togo in 2011?
Make the answer very short. -10.67. What is the difference between the Emissions(in percent) in China in 2007 and the Emissions(in percent) in Swaziland in 2011?
Your answer should be very brief. -49.5. What is the difference between the Emissions(in percent) in China in 2007 and the Emissions(in percent) in Togo in 2011?
Give a very brief answer. -42.85. What is the difference between the Emissions(in percent) in Swaziland in 2007 and the Emissions(in percent) in Togo in 2011?
Your answer should be compact. 4.72. What is the difference between the Emissions(in percent) of Belgium in 2008 and the Emissions(in percent) of China in 2009?
Provide a succinct answer. 35.18. What is the difference between the Emissions(in percent) in Belgium in 2008 and the Emissions(in percent) in Swaziland in 2009?
Offer a terse response. -14.6. What is the difference between the Emissions(in percent) of Belgium in 2008 and the Emissions(in percent) of Togo in 2009?
Offer a terse response. -16.67. What is the difference between the Emissions(in percent) in China in 2008 and the Emissions(in percent) in Swaziland in 2009?
Your answer should be very brief. -48.77. What is the difference between the Emissions(in percent) of China in 2008 and the Emissions(in percent) of Togo in 2009?
Give a very brief answer. -50.84. What is the difference between the Emissions(in percent) of Swaziland in 2008 and the Emissions(in percent) of Togo in 2009?
Ensure brevity in your answer.  -3.37. What is the difference between the Emissions(in percent) of Belgium in 2008 and the Emissions(in percent) of China in 2010?
Ensure brevity in your answer.  35.03. What is the difference between the Emissions(in percent) in Belgium in 2008 and the Emissions(in percent) in Swaziland in 2010?
Give a very brief answer. -15.76. What is the difference between the Emissions(in percent) of Belgium in 2008 and the Emissions(in percent) of Togo in 2010?
Provide a succinct answer. -17.83. What is the difference between the Emissions(in percent) of China in 2008 and the Emissions(in percent) of Swaziland in 2010?
Provide a short and direct response. -49.92. What is the difference between the Emissions(in percent) in China in 2008 and the Emissions(in percent) in Togo in 2010?
Ensure brevity in your answer.  -52. What is the difference between the Emissions(in percent) in Swaziland in 2008 and the Emissions(in percent) in Togo in 2010?
Keep it short and to the point. -4.53. What is the difference between the Emissions(in percent) of Belgium in 2008 and the Emissions(in percent) of China in 2011?
Offer a very short reply. 36.5. What is the difference between the Emissions(in percent) of Belgium in 2008 and the Emissions(in percent) of Swaziland in 2011?
Your answer should be compact. -15.43. What is the difference between the Emissions(in percent) of Belgium in 2008 and the Emissions(in percent) of Togo in 2011?
Make the answer very short. -8.79. What is the difference between the Emissions(in percent) in China in 2008 and the Emissions(in percent) in Swaziland in 2011?
Your answer should be very brief. -49.6. What is the difference between the Emissions(in percent) in China in 2008 and the Emissions(in percent) in Togo in 2011?
Keep it short and to the point. -42.95. What is the difference between the Emissions(in percent) in Swaziland in 2008 and the Emissions(in percent) in Togo in 2011?
Ensure brevity in your answer.  4.52. What is the difference between the Emissions(in percent) in Belgium in 2009 and the Emissions(in percent) in China in 2010?
Provide a short and direct response. 37.64. What is the difference between the Emissions(in percent) of Belgium in 2009 and the Emissions(in percent) of Swaziland in 2010?
Your response must be concise. -13.15. What is the difference between the Emissions(in percent) of Belgium in 2009 and the Emissions(in percent) of Togo in 2010?
Offer a very short reply. -15.22. What is the difference between the Emissions(in percent) of China in 2009 and the Emissions(in percent) of Swaziland in 2010?
Provide a short and direct response. -50.94. What is the difference between the Emissions(in percent) in China in 2009 and the Emissions(in percent) in Togo in 2010?
Your response must be concise. -53.01. What is the difference between the Emissions(in percent) in Swaziland in 2009 and the Emissions(in percent) in Togo in 2010?
Your answer should be compact. -3.23. What is the difference between the Emissions(in percent) in Belgium in 2009 and the Emissions(in percent) in China in 2011?
Your answer should be very brief. 39.11. What is the difference between the Emissions(in percent) in Belgium in 2009 and the Emissions(in percent) in Swaziland in 2011?
Your answer should be very brief. -12.82. What is the difference between the Emissions(in percent) in Belgium in 2009 and the Emissions(in percent) in Togo in 2011?
Your answer should be very brief. -6.18. What is the difference between the Emissions(in percent) in China in 2009 and the Emissions(in percent) in Swaziland in 2011?
Make the answer very short. -50.61. What is the difference between the Emissions(in percent) in China in 2009 and the Emissions(in percent) in Togo in 2011?
Offer a terse response. -43.97. What is the difference between the Emissions(in percent) of Swaziland in 2009 and the Emissions(in percent) of Togo in 2011?
Provide a succinct answer. 5.82. What is the difference between the Emissions(in percent) of Belgium in 2010 and the Emissions(in percent) of China in 2011?
Keep it short and to the point. 36.98. What is the difference between the Emissions(in percent) in Belgium in 2010 and the Emissions(in percent) in Swaziland in 2011?
Offer a very short reply. -14.94. What is the difference between the Emissions(in percent) of Belgium in 2010 and the Emissions(in percent) of Togo in 2011?
Provide a short and direct response. -8.3. What is the difference between the Emissions(in percent) in China in 2010 and the Emissions(in percent) in Swaziland in 2011?
Offer a terse response. -50.47. What is the difference between the Emissions(in percent) in China in 2010 and the Emissions(in percent) in Togo in 2011?
Offer a very short reply. -43.82. What is the difference between the Emissions(in percent) of Swaziland in 2010 and the Emissions(in percent) of Togo in 2011?
Make the answer very short. 6.97. What is the average Emissions(in percent) in Belgium per year?
Provide a short and direct response. 48.72. What is the average Emissions(in percent) of China per year?
Offer a very short reply. 14.67. What is the average Emissions(in percent) of Swaziland per year?
Your response must be concise. 62.92. What is the average Emissions(in percent) in Togo per year?
Give a very brief answer. 65.59. In the year 2004, what is the difference between the Emissions(in percent) of Belgium and Emissions(in percent) of China?
Offer a very short reply. 31.2. In the year 2004, what is the difference between the Emissions(in percent) in Belgium and Emissions(in percent) in Swaziland?
Offer a terse response. -13.81. In the year 2004, what is the difference between the Emissions(in percent) of Belgium and Emissions(in percent) of Togo?
Your answer should be very brief. -23.28. In the year 2004, what is the difference between the Emissions(in percent) of China and Emissions(in percent) of Swaziland?
Your answer should be very brief. -45.01. In the year 2004, what is the difference between the Emissions(in percent) in China and Emissions(in percent) in Togo?
Give a very brief answer. -54.48. In the year 2004, what is the difference between the Emissions(in percent) in Swaziland and Emissions(in percent) in Togo?
Your response must be concise. -9.47. In the year 2005, what is the difference between the Emissions(in percent) of Belgium and Emissions(in percent) of China?
Keep it short and to the point. 32.67. In the year 2005, what is the difference between the Emissions(in percent) in Belgium and Emissions(in percent) in Swaziland?
Provide a short and direct response. -13.9. In the year 2005, what is the difference between the Emissions(in percent) of Belgium and Emissions(in percent) of Togo?
Your answer should be compact. -21.81. In the year 2005, what is the difference between the Emissions(in percent) in China and Emissions(in percent) in Swaziland?
Your response must be concise. -46.58. In the year 2005, what is the difference between the Emissions(in percent) of China and Emissions(in percent) of Togo?
Ensure brevity in your answer.  -54.49. In the year 2005, what is the difference between the Emissions(in percent) in Swaziland and Emissions(in percent) in Togo?
Your response must be concise. -7.91. In the year 2006, what is the difference between the Emissions(in percent) of Belgium and Emissions(in percent) of China?
Keep it short and to the point. 32.22. In the year 2006, what is the difference between the Emissions(in percent) of Belgium and Emissions(in percent) of Swaziland?
Make the answer very short. -14.65. In the year 2006, what is the difference between the Emissions(in percent) in Belgium and Emissions(in percent) in Togo?
Provide a succinct answer. -19.83. In the year 2006, what is the difference between the Emissions(in percent) of China and Emissions(in percent) of Swaziland?
Offer a terse response. -46.87. In the year 2006, what is the difference between the Emissions(in percent) in China and Emissions(in percent) in Togo?
Keep it short and to the point. -52.05. In the year 2006, what is the difference between the Emissions(in percent) in Swaziland and Emissions(in percent) in Togo?
Provide a succinct answer. -5.17. In the year 2007, what is the difference between the Emissions(in percent) of Belgium and Emissions(in percent) of China?
Make the answer very short. 32.18. In the year 2007, what is the difference between the Emissions(in percent) in Belgium and Emissions(in percent) in Swaziland?
Your response must be concise. -15.4. In the year 2007, what is the difference between the Emissions(in percent) of Belgium and Emissions(in percent) of Togo?
Provide a short and direct response. -17.92. In the year 2007, what is the difference between the Emissions(in percent) in China and Emissions(in percent) in Swaziland?
Give a very brief answer. -47.57. In the year 2007, what is the difference between the Emissions(in percent) of China and Emissions(in percent) of Togo?
Your answer should be compact. -50.1. In the year 2007, what is the difference between the Emissions(in percent) of Swaziland and Emissions(in percent) of Togo?
Give a very brief answer. -2.52. In the year 2008, what is the difference between the Emissions(in percent) of Belgium and Emissions(in percent) of China?
Offer a terse response. 34.16. In the year 2008, what is the difference between the Emissions(in percent) in Belgium and Emissions(in percent) in Swaziland?
Make the answer very short. -13.3. In the year 2008, what is the difference between the Emissions(in percent) of Belgium and Emissions(in percent) of Togo?
Provide a succinct answer. -12.11. In the year 2008, what is the difference between the Emissions(in percent) in China and Emissions(in percent) in Swaziland?
Offer a very short reply. -47.47. In the year 2008, what is the difference between the Emissions(in percent) of China and Emissions(in percent) of Togo?
Offer a very short reply. -46.28. In the year 2008, what is the difference between the Emissions(in percent) in Swaziland and Emissions(in percent) in Togo?
Ensure brevity in your answer.  1.19. In the year 2009, what is the difference between the Emissions(in percent) in Belgium and Emissions(in percent) in China?
Your response must be concise. 37.79. In the year 2009, what is the difference between the Emissions(in percent) of Belgium and Emissions(in percent) of Swaziland?
Give a very brief answer. -11.99. In the year 2009, what is the difference between the Emissions(in percent) of Belgium and Emissions(in percent) of Togo?
Offer a very short reply. -14.06. In the year 2009, what is the difference between the Emissions(in percent) in China and Emissions(in percent) in Swaziland?
Your answer should be very brief. -49.78. In the year 2009, what is the difference between the Emissions(in percent) of China and Emissions(in percent) of Togo?
Ensure brevity in your answer.  -51.85. In the year 2009, what is the difference between the Emissions(in percent) in Swaziland and Emissions(in percent) in Togo?
Offer a very short reply. -2.07. In the year 2010, what is the difference between the Emissions(in percent) in Belgium and Emissions(in percent) in China?
Offer a very short reply. 35.52. In the year 2010, what is the difference between the Emissions(in percent) of Belgium and Emissions(in percent) of Swaziland?
Your answer should be compact. -15.27. In the year 2010, what is the difference between the Emissions(in percent) in Belgium and Emissions(in percent) in Togo?
Keep it short and to the point. -17.35. In the year 2010, what is the difference between the Emissions(in percent) of China and Emissions(in percent) of Swaziland?
Keep it short and to the point. -50.8. In the year 2010, what is the difference between the Emissions(in percent) of China and Emissions(in percent) of Togo?
Your answer should be very brief. -52.87. In the year 2010, what is the difference between the Emissions(in percent) of Swaziland and Emissions(in percent) of Togo?
Ensure brevity in your answer.  -2.07. In the year 2011, what is the difference between the Emissions(in percent) of Belgium and Emissions(in percent) of China?
Keep it short and to the point. 36.67. In the year 2011, what is the difference between the Emissions(in percent) of Belgium and Emissions(in percent) of Swaziland?
Provide a succinct answer. -15.26. In the year 2011, what is the difference between the Emissions(in percent) in Belgium and Emissions(in percent) in Togo?
Provide a short and direct response. -8.61. In the year 2011, what is the difference between the Emissions(in percent) of China and Emissions(in percent) of Swaziland?
Offer a terse response. -51.93. In the year 2011, what is the difference between the Emissions(in percent) of China and Emissions(in percent) of Togo?
Make the answer very short. -45.28. In the year 2011, what is the difference between the Emissions(in percent) in Swaziland and Emissions(in percent) in Togo?
Your answer should be compact. 6.64. What is the ratio of the Emissions(in percent) of Belgium in 2004 to that in 2005?
Offer a very short reply. 1. What is the ratio of the Emissions(in percent) of China in 2004 to that in 2005?
Provide a short and direct response. 1.08. What is the ratio of the Emissions(in percent) of Togo in 2004 to that in 2005?
Give a very brief answer. 1.02. What is the ratio of the Emissions(in percent) in Belgium in 2004 to that in 2006?
Ensure brevity in your answer.  1.01. What is the ratio of the Emissions(in percent) of China in 2004 to that in 2006?
Your answer should be very brief. 1.11. What is the ratio of the Emissions(in percent) in Swaziland in 2004 to that in 2006?
Offer a terse response. 1. What is the ratio of the Emissions(in percent) of Togo in 2004 to that in 2006?
Your response must be concise. 1.06. What is the ratio of the Emissions(in percent) in Belgium in 2004 to that in 2007?
Make the answer very short. 1.02. What is the ratio of the Emissions(in percent) of China in 2004 to that in 2007?
Provide a short and direct response. 1.14. What is the ratio of the Emissions(in percent) of Swaziland in 2004 to that in 2007?
Make the answer very short. 0.99. What is the ratio of the Emissions(in percent) in Togo in 2004 to that in 2007?
Offer a very short reply. 1.1. What is the ratio of the Emissions(in percent) of Belgium in 2004 to that in 2008?
Ensure brevity in your answer.  0.98. What is the ratio of the Emissions(in percent) in China in 2004 to that in 2008?
Offer a terse response. 1.15. What is the ratio of the Emissions(in percent) of Togo in 2004 to that in 2008?
Provide a short and direct response. 1.17. What is the ratio of the Emissions(in percent) in Belgium in 2004 to that in 2009?
Your response must be concise. 0.93. What is the ratio of the Emissions(in percent) in China in 2004 to that in 2009?
Give a very brief answer. 1.23. What is the ratio of the Emissions(in percent) in Togo in 2004 to that in 2009?
Your answer should be very brief. 1.09. What is the ratio of the Emissions(in percent) of Belgium in 2004 to that in 2010?
Give a very brief answer. 0.97. What is the ratio of the Emissions(in percent) of China in 2004 to that in 2010?
Give a very brief answer. 1.22. What is the ratio of the Emissions(in percent) in Swaziland in 2004 to that in 2010?
Your answer should be very brief. 0.96. What is the ratio of the Emissions(in percent) of Togo in 2004 to that in 2010?
Your answer should be compact. 1.07. What is the ratio of the Emissions(in percent) in Belgium in 2004 to that in 2011?
Offer a very short reply. 0.98. What is the ratio of the Emissions(in percent) of China in 2004 to that in 2011?
Ensure brevity in your answer.  1.36. What is the ratio of the Emissions(in percent) in Swaziland in 2004 to that in 2011?
Offer a terse response. 0.96. What is the ratio of the Emissions(in percent) of Togo in 2004 to that in 2011?
Your answer should be very brief. 1.24. What is the ratio of the Emissions(in percent) in Belgium in 2005 to that in 2006?
Your answer should be very brief. 1.02. What is the ratio of the Emissions(in percent) in China in 2005 to that in 2006?
Offer a terse response. 1.03. What is the ratio of the Emissions(in percent) in Togo in 2005 to that in 2006?
Keep it short and to the point. 1.04. What is the ratio of the Emissions(in percent) of Belgium in 2005 to that in 2007?
Offer a terse response. 1.03. What is the ratio of the Emissions(in percent) in China in 2005 to that in 2007?
Your answer should be compact. 1.05. What is the ratio of the Emissions(in percent) in Togo in 2005 to that in 2007?
Give a very brief answer. 1.08. What is the ratio of the Emissions(in percent) of Belgium in 2005 to that in 2008?
Keep it short and to the point. 0.99. What is the ratio of the Emissions(in percent) in China in 2005 to that in 2008?
Keep it short and to the point. 1.06. What is the ratio of the Emissions(in percent) of Swaziland in 2005 to that in 2008?
Your answer should be compact. 1. What is the ratio of the Emissions(in percent) of Togo in 2005 to that in 2008?
Give a very brief answer. 1.15. What is the ratio of the Emissions(in percent) in Belgium in 2005 to that in 2009?
Keep it short and to the point. 0.94. What is the ratio of the Emissions(in percent) in China in 2005 to that in 2009?
Your response must be concise. 1.14. What is the ratio of the Emissions(in percent) in Swaziland in 2005 to that in 2009?
Offer a terse response. 0.98. What is the ratio of the Emissions(in percent) of Togo in 2005 to that in 2009?
Your answer should be compact. 1.07. What is the ratio of the Emissions(in percent) in Belgium in 2005 to that in 2010?
Your answer should be compact. 0.98. What is the ratio of the Emissions(in percent) of China in 2005 to that in 2010?
Your answer should be very brief. 1.13. What is the ratio of the Emissions(in percent) in Swaziland in 2005 to that in 2010?
Provide a succinct answer. 0.96. What is the ratio of the Emissions(in percent) in Togo in 2005 to that in 2010?
Make the answer very short. 1.05. What is the ratio of the Emissions(in percent) of Belgium in 2005 to that in 2011?
Ensure brevity in your answer.  0.98. What is the ratio of the Emissions(in percent) of China in 2005 to that in 2011?
Your answer should be compact. 1.26. What is the ratio of the Emissions(in percent) in Swaziland in 2005 to that in 2011?
Keep it short and to the point. 0.97. What is the ratio of the Emissions(in percent) of Togo in 2005 to that in 2011?
Keep it short and to the point. 1.22. What is the ratio of the Emissions(in percent) of China in 2006 to that in 2007?
Your answer should be compact. 1.03. What is the ratio of the Emissions(in percent) of Swaziland in 2006 to that in 2007?
Keep it short and to the point. 0.99. What is the ratio of the Emissions(in percent) of Togo in 2006 to that in 2007?
Keep it short and to the point. 1.04. What is the ratio of the Emissions(in percent) of Belgium in 2006 to that in 2008?
Your response must be concise. 0.97. What is the ratio of the Emissions(in percent) in China in 2006 to that in 2008?
Your response must be concise. 1.03. What is the ratio of the Emissions(in percent) of Swaziland in 2006 to that in 2008?
Offer a terse response. 1. What is the ratio of the Emissions(in percent) of Togo in 2006 to that in 2008?
Your response must be concise. 1.1. What is the ratio of the Emissions(in percent) of Belgium in 2006 to that in 2009?
Offer a very short reply. 0.92. What is the ratio of the Emissions(in percent) in China in 2006 to that in 2009?
Offer a terse response. 1.11. What is the ratio of the Emissions(in percent) in Swaziland in 2006 to that in 2009?
Your response must be concise. 0.98. What is the ratio of the Emissions(in percent) of Togo in 2006 to that in 2009?
Give a very brief answer. 1.03. What is the ratio of the Emissions(in percent) in Belgium in 2006 to that in 2010?
Make the answer very short. 0.96. What is the ratio of the Emissions(in percent) of China in 2006 to that in 2010?
Provide a succinct answer. 1.1. What is the ratio of the Emissions(in percent) of Swaziland in 2006 to that in 2010?
Give a very brief answer. 0.96. What is the ratio of the Emissions(in percent) of Togo in 2006 to that in 2010?
Your answer should be compact. 1.01. What is the ratio of the Emissions(in percent) of Belgium in 2006 to that in 2011?
Provide a short and direct response. 0.97. What is the ratio of the Emissions(in percent) of China in 2006 to that in 2011?
Give a very brief answer. 1.23. What is the ratio of the Emissions(in percent) of Swaziland in 2006 to that in 2011?
Offer a very short reply. 0.97. What is the ratio of the Emissions(in percent) in Togo in 2006 to that in 2011?
Provide a succinct answer. 1.17. What is the ratio of the Emissions(in percent) of Belgium in 2007 to that in 2008?
Offer a terse response. 0.96. What is the ratio of the Emissions(in percent) of China in 2007 to that in 2008?
Keep it short and to the point. 1.01. What is the ratio of the Emissions(in percent) of Togo in 2007 to that in 2008?
Provide a short and direct response. 1.06. What is the ratio of the Emissions(in percent) in Belgium in 2007 to that in 2009?
Provide a short and direct response. 0.91. What is the ratio of the Emissions(in percent) in China in 2007 to that in 2009?
Your response must be concise. 1.08. What is the ratio of the Emissions(in percent) in Swaziland in 2007 to that in 2009?
Offer a very short reply. 0.98. What is the ratio of the Emissions(in percent) in Togo in 2007 to that in 2009?
Your response must be concise. 0.99. What is the ratio of the Emissions(in percent) in Belgium in 2007 to that in 2010?
Your answer should be very brief. 0.95. What is the ratio of the Emissions(in percent) of China in 2007 to that in 2010?
Keep it short and to the point. 1.07. What is the ratio of the Emissions(in percent) of Swaziland in 2007 to that in 2010?
Make the answer very short. 0.97. What is the ratio of the Emissions(in percent) of Belgium in 2007 to that in 2011?
Give a very brief answer. 0.96. What is the ratio of the Emissions(in percent) in China in 2007 to that in 2011?
Your answer should be very brief. 1.2. What is the ratio of the Emissions(in percent) of Swaziland in 2007 to that in 2011?
Keep it short and to the point. 0.97. What is the ratio of the Emissions(in percent) of Togo in 2007 to that in 2011?
Make the answer very short. 1.13. What is the ratio of the Emissions(in percent) in Belgium in 2008 to that in 2009?
Offer a terse response. 0.95. What is the ratio of the Emissions(in percent) of China in 2008 to that in 2009?
Make the answer very short. 1.07. What is the ratio of the Emissions(in percent) of Swaziland in 2008 to that in 2009?
Keep it short and to the point. 0.98. What is the ratio of the Emissions(in percent) in Togo in 2008 to that in 2009?
Your answer should be compact. 0.93. What is the ratio of the Emissions(in percent) of Belgium in 2008 to that in 2010?
Your answer should be very brief. 0.99. What is the ratio of the Emissions(in percent) in China in 2008 to that in 2010?
Keep it short and to the point. 1.06. What is the ratio of the Emissions(in percent) in Swaziland in 2008 to that in 2010?
Keep it short and to the point. 0.96. What is the ratio of the Emissions(in percent) in Togo in 2008 to that in 2010?
Offer a terse response. 0.91. What is the ratio of the Emissions(in percent) of China in 2008 to that in 2011?
Offer a terse response. 1.19. What is the ratio of the Emissions(in percent) in Swaziland in 2008 to that in 2011?
Make the answer very short. 0.97. What is the ratio of the Emissions(in percent) of Togo in 2008 to that in 2011?
Give a very brief answer. 1.06. What is the ratio of the Emissions(in percent) in Belgium in 2009 to that in 2010?
Provide a short and direct response. 1.04. What is the ratio of the Emissions(in percent) in China in 2009 to that in 2010?
Make the answer very short. 0.99. What is the ratio of the Emissions(in percent) of Swaziland in 2009 to that in 2010?
Keep it short and to the point. 0.98. What is the ratio of the Emissions(in percent) in Togo in 2009 to that in 2010?
Give a very brief answer. 0.98. What is the ratio of the Emissions(in percent) in Belgium in 2009 to that in 2011?
Give a very brief answer. 1.05. What is the ratio of the Emissions(in percent) of China in 2009 to that in 2011?
Offer a terse response. 1.11. What is the ratio of the Emissions(in percent) of Swaziland in 2009 to that in 2011?
Your response must be concise. 0.99. What is the ratio of the Emissions(in percent) in Togo in 2009 to that in 2011?
Offer a very short reply. 1.14. What is the ratio of the Emissions(in percent) of Belgium in 2010 to that in 2011?
Ensure brevity in your answer.  1.01. What is the ratio of the Emissions(in percent) in China in 2010 to that in 2011?
Ensure brevity in your answer.  1.12. What is the ratio of the Emissions(in percent) of Togo in 2010 to that in 2011?
Offer a terse response. 1.16. What is the difference between the highest and the second highest Emissions(in percent) in Belgium?
Provide a short and direct response. 2.12. What is the difference between the highest and the second highest Emissions(in percent) of China?
Your answer should be compact. 1.26. What is the difference between the highest and the second highest Emissions(in percent) of Swaziland?
Provide a short and direct response. 0.33. What is the difference between the highest and the second highest Emissions(in percent) in Togo?
Keep it short and to the point. 1.25. What is the difference between the highest and the lowest Emissions(in percent) of Belgium?
Provide a succinct answer. 4.5. What is the difference between the highest and the lowest Emissions(in percent) of China?
Ensure brevity in your answer.  4.5. What is the difference between the highest and the lowest Emissions(in percent) in Swaziland?
Offer a terse response. 2.74. What is the difference between the highest and the lowest Emissions(in percent) in Togo?
Your response must be concise. 13.7. 